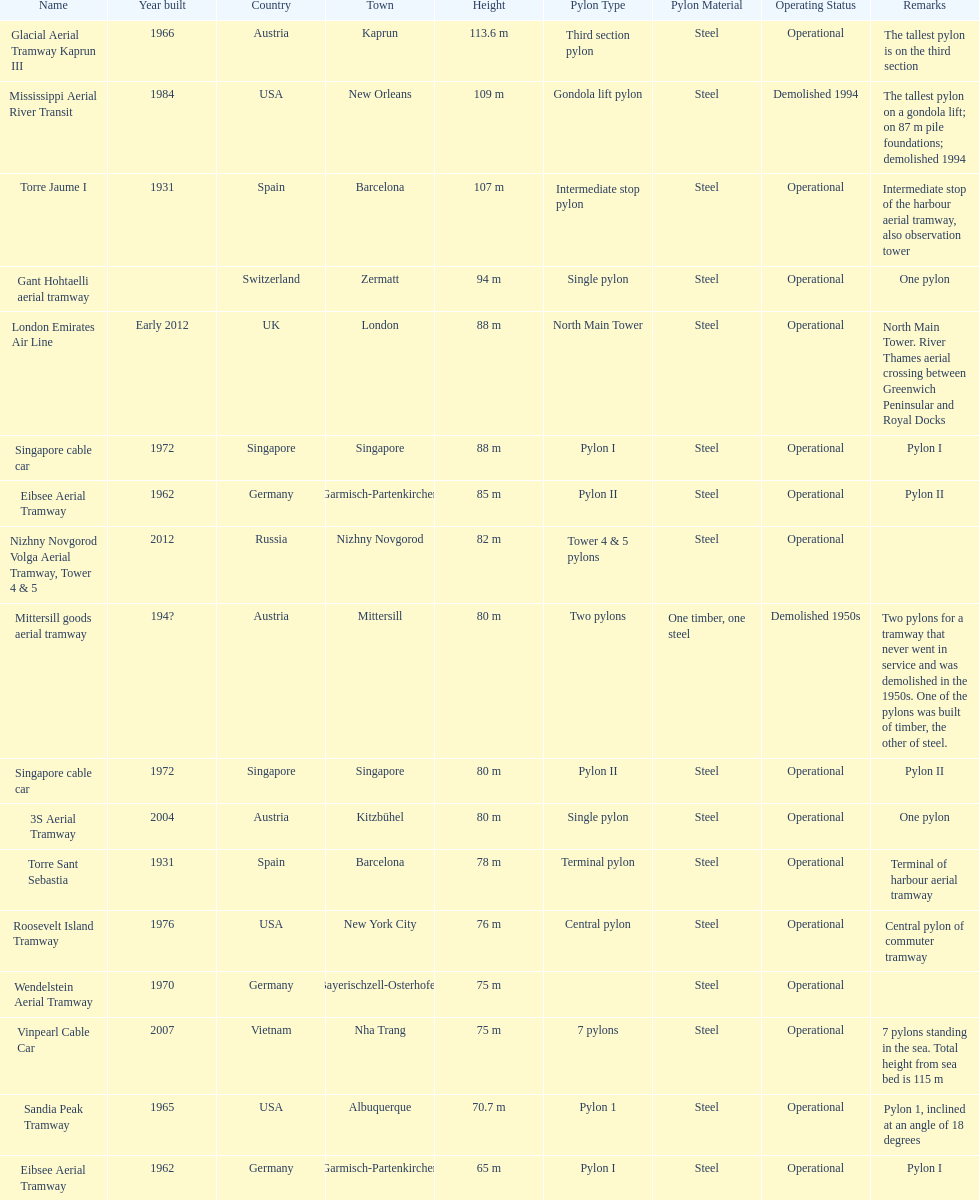What is the total number of tallest pylons in austria? 3. 